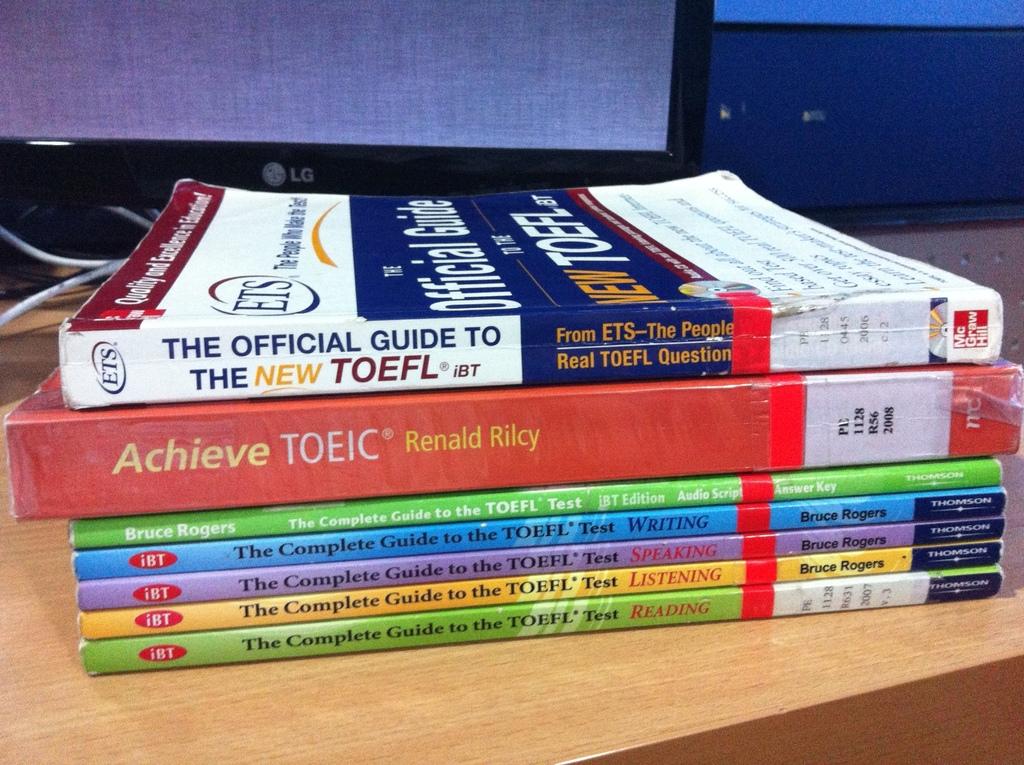What are the book titles?
Give a very brief answer. The complete guide to the toefl test. What is the subject of the bottom book?
Provide a succinct answer. Reading. 